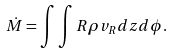Convert formula to latex. <formula><loc_0><loc_0><loc_500><loc_500>\dot { M } = \int \int R \rho v _ { R } d z d \phi .</formula> 